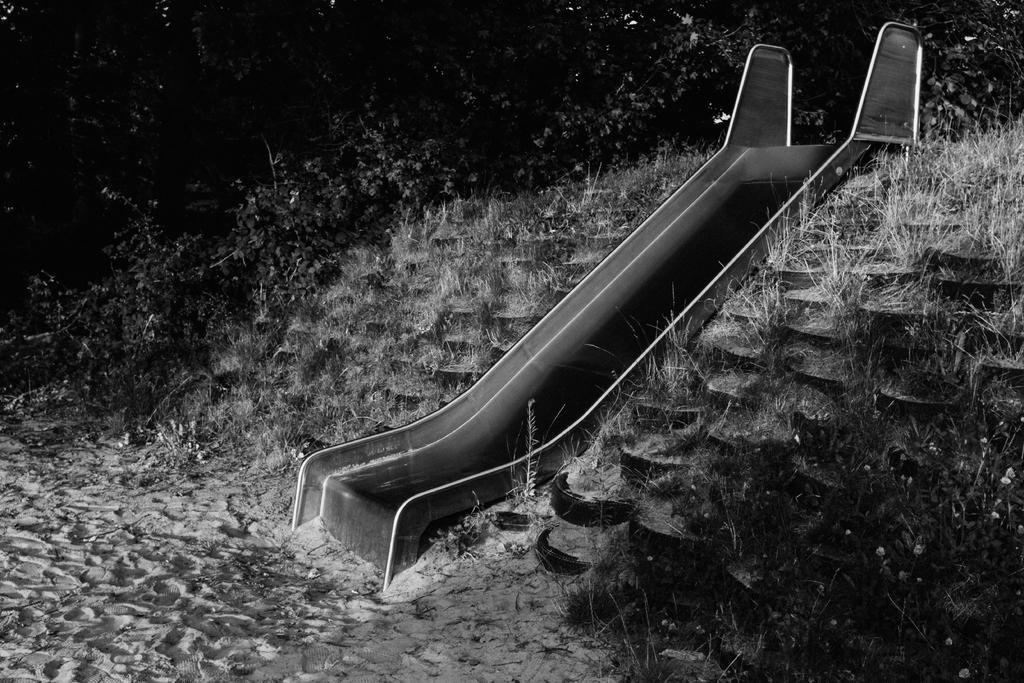Could you give a brief overview of what you see in this image? This is the black and white image and we can see the slide and we can see the grass on the ground and there are some trees in the background. 